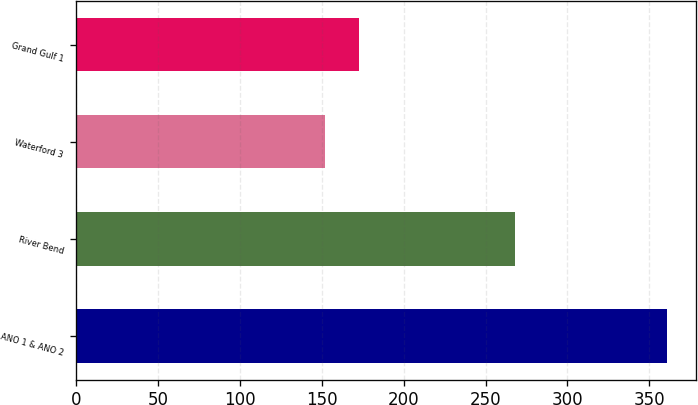Convert chart to OTSL. <chart><loc_0><loc_0><loc_500><loc_500><bar_chart><fcel>ANO 1 & ANO 2<fcel>River Bend<fcel>Waterford 3<fcel>Grand Gulf 1<nl><fcel>360.5<fcel>267.9<fcel>152<fcel>172.9<nl></chart> 